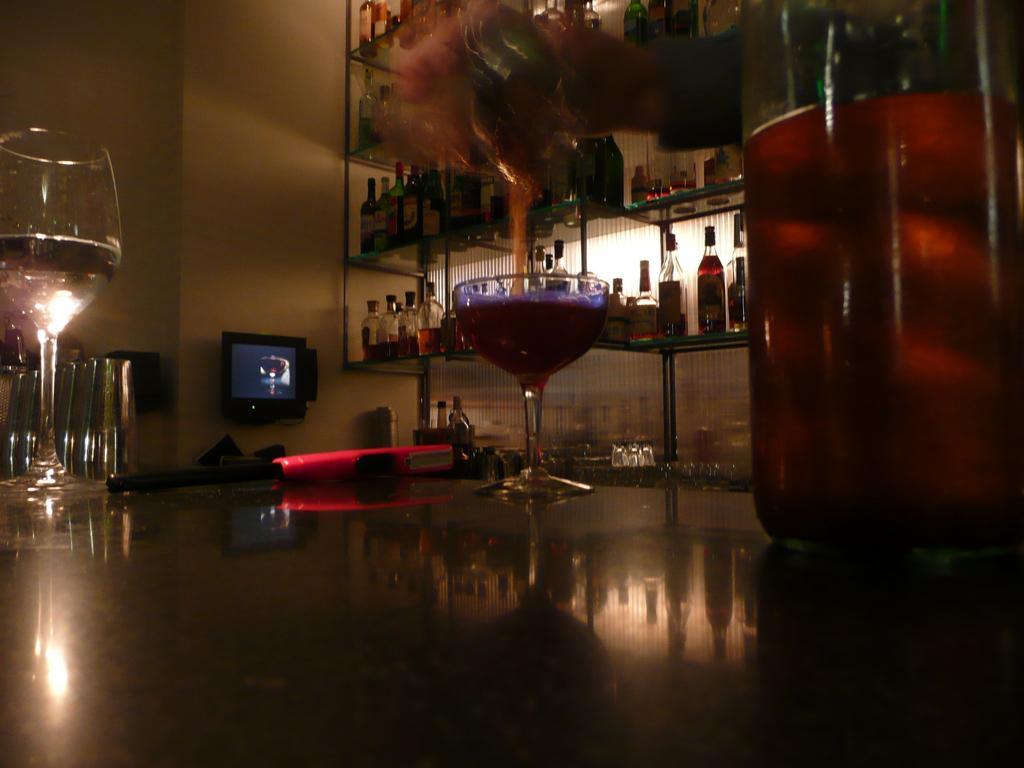Please provide a concise description of this image. This is a glass table where a wine bottle and a glass of wine are kept on it. Here we can see a bunch of wine bottles which are kept on this glass shelf. This is a television which is fixed to a wall. 